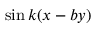<formula> <loc_0><loc_0><loc_500><loc_500>\sin { k ( x - b y ) }</formula> 